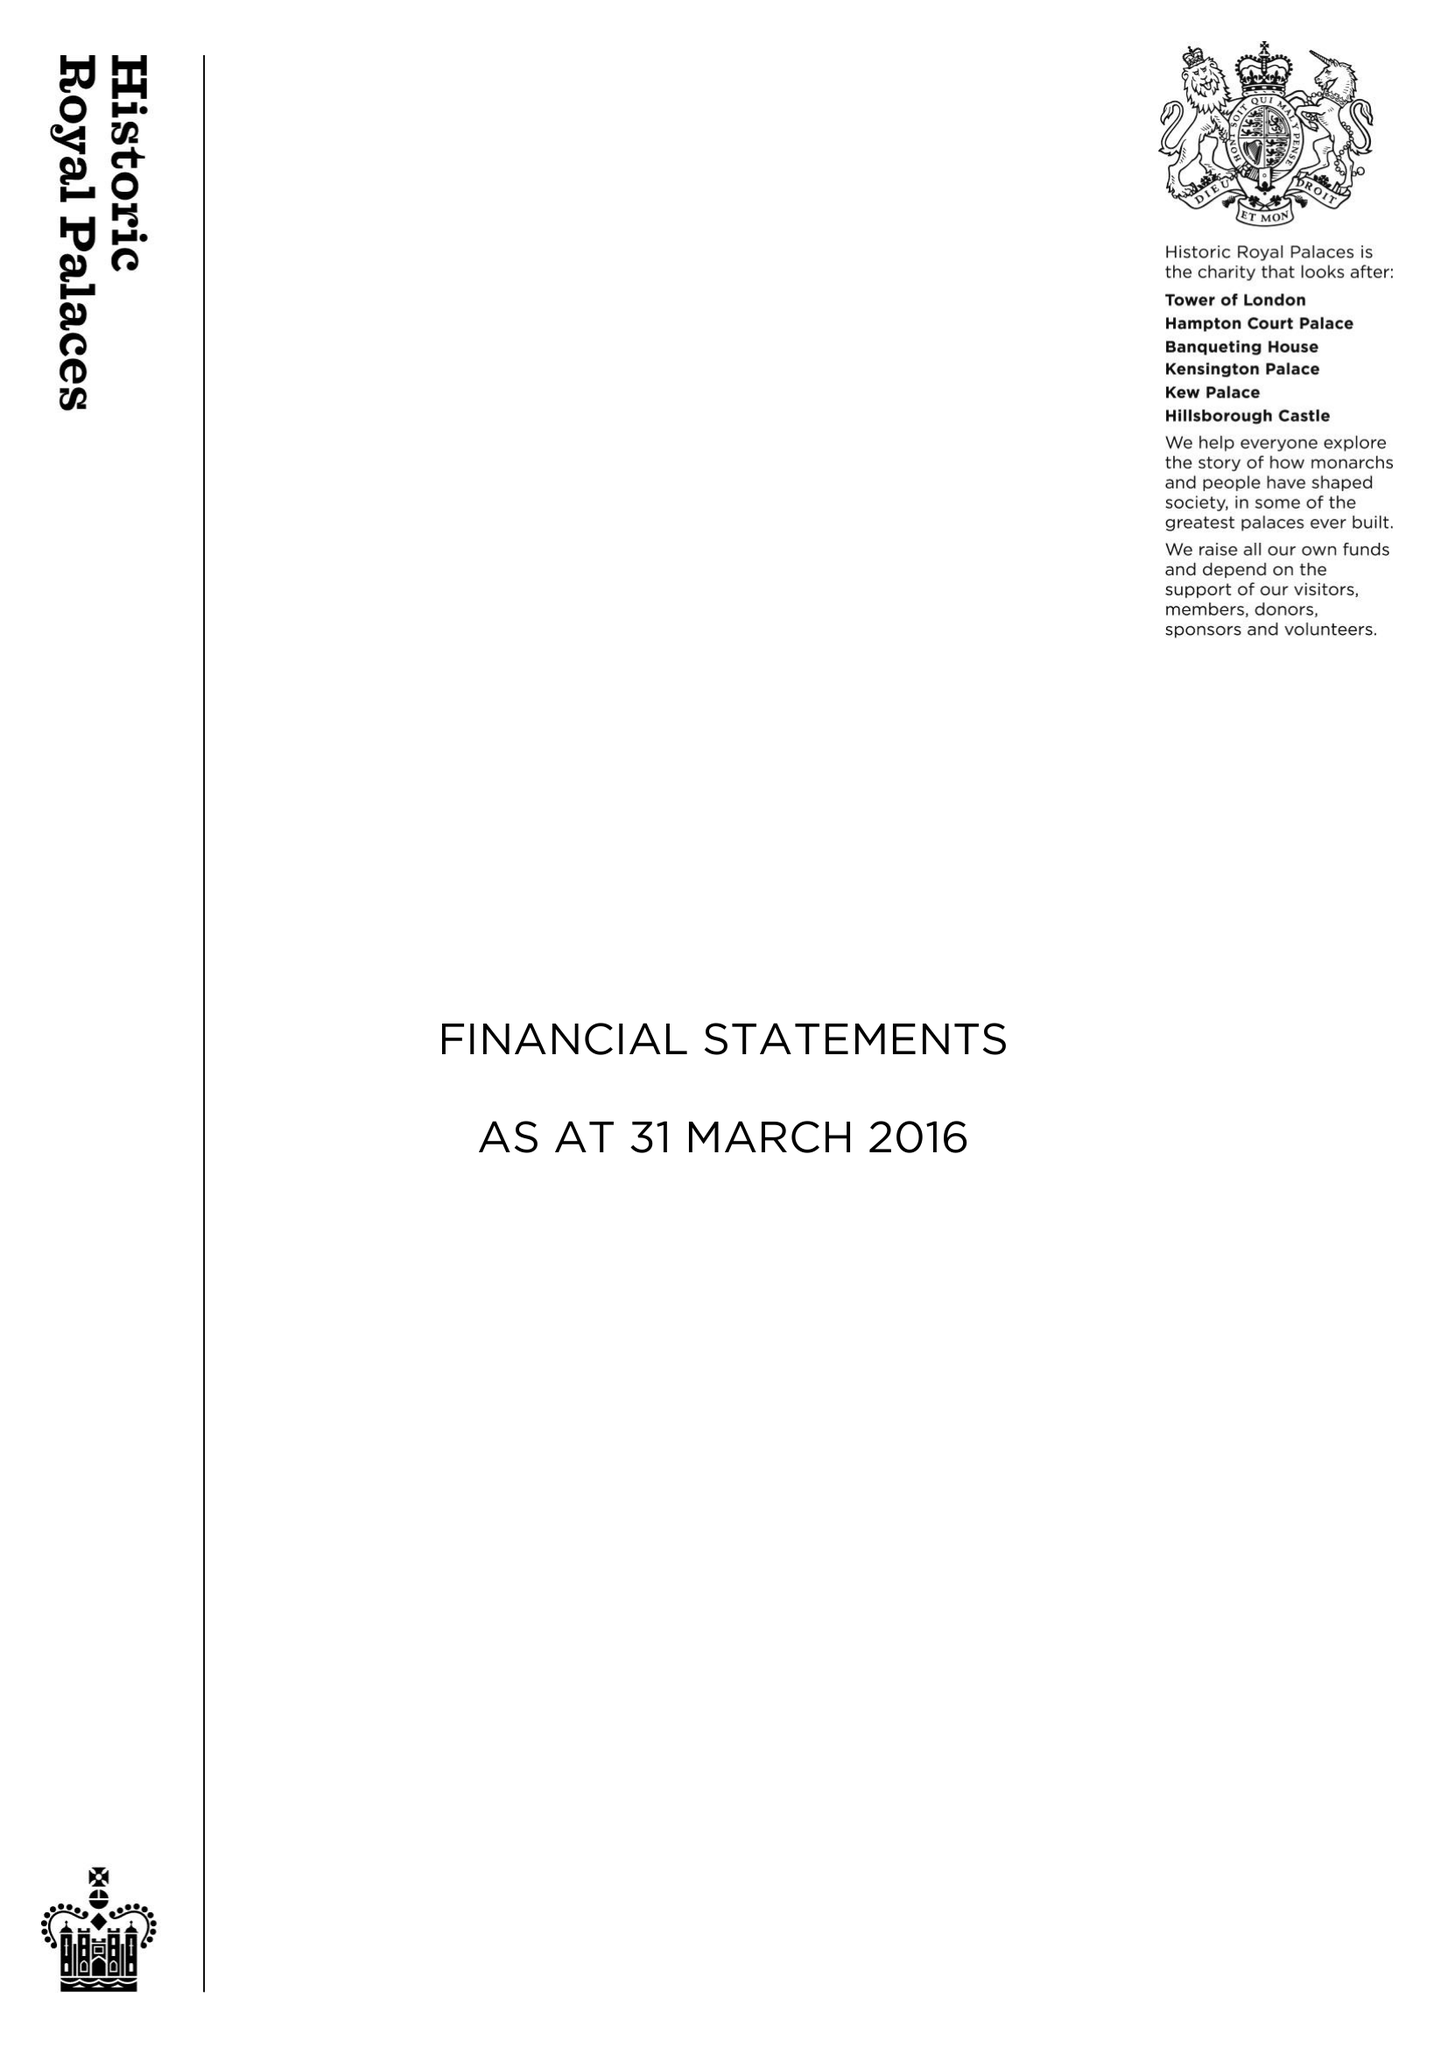What is the value for the charity_name?
Answer the question using a single word or phrase. Historic Royal Palaces 